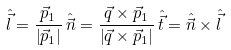Convert formula to latex. <formula><loc_0><loc_0><loc_500><loc_500>\hat { \vec { l } } = \frac { \vec { p } _ { 1 } } { \left | \vec { p } _ { 1 } \right | } \, \hat { \vec { n } } = \frac { \vec { q } \times \vec { p } _ { 1 } } { \left | \vec { q } \times \vec { p } _ { 1 } \right | } \, \hat { \vec { t } } = \hat { \vec { n } } \times \hat { \vec { l } } \,</formula> 